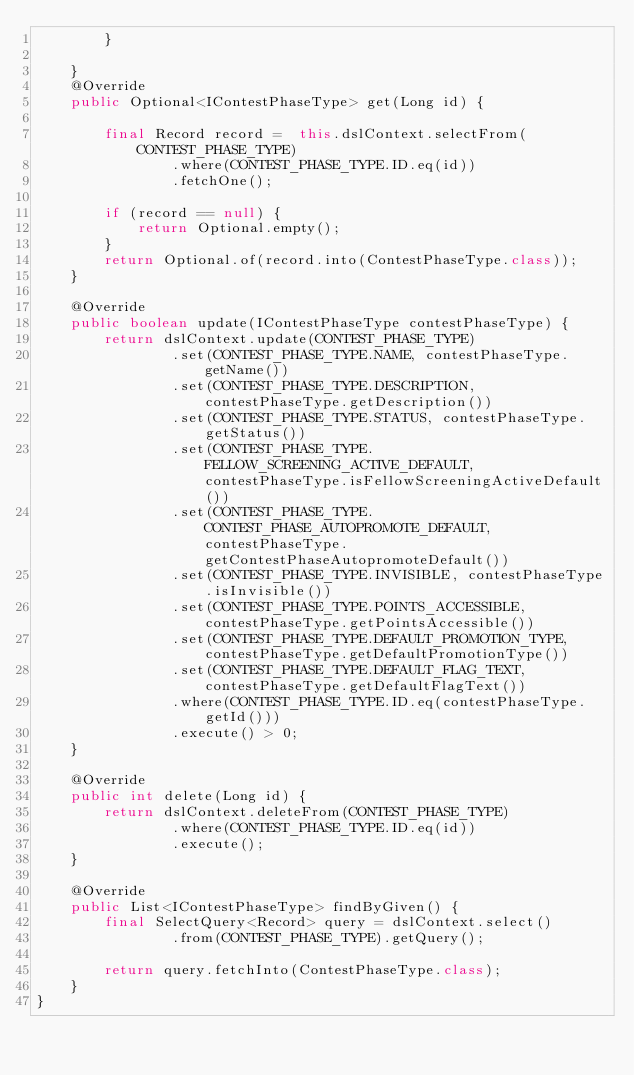Convert code to text. <code><loc_0><loc_0><loc_500><loc_500><_Java_>        }

    }
    @Override
    public Optional<IContestPhaseType> get(Long id) {

        final Record record =  this.dslContext.selectFrom(CONTEST_PHASE_TYPE)
                .where(CONTEST_PHASE_TYPE.ID.eq(id))
                .fetchOne();

        if (record == null) {
            return Optional.empty();
        }
        return Optional.of(record.into(ContestPhaseType.class));
    }

    @Override
    public boolean update(IContestPhaseType contestPhaseType) {
        return dslContext.update(CONTEST_PHASE_TYPE)
                .set(CONTEST_PHASE_TYPE.NAME, contestPhaseType.getName())
                .set(CONTEST_PHASE_TYPE.DESCRIPTION, contestPhaseType.getDescription())
                .set(CONTEST_PHASE_TYPE.STATUS, contestPhaseType.getStatus())
                .set(CONTEST_PHASE_TYPE.FELLOW_SCREENING_ACTIVE_DEFAULT, contestPhaseType.isFellowScreeningActiveDefault())
                .set(CONTEST_PHASE_TYPE.CONTEST_PHASE_AUTOPROMOTE_DEFAULT, contestPhaseType.getContestPhaseAutopromoteDefault())
                .set(CONTEST_PHASE_TYPE.INVISIBLE, contestPhaseType.isInvisible())
                .set(CONTEST_PHASE_TYPE.POINTS_ACCESSIBLE, contestPhaseType.getPointsAccessible())
                .set(CONTEST_PHASE_TYPE.DEFAULT_PROMOTION_TYPE, contestPhaseType.getDefaultPromotionType())
                .set(CONTEST_PHASE_TYPE.DEFAULT_FLAG_TEXT, contestPhaseType.getDefaultFlagText())
                .where(CONTEST_PHASE_TYPE.ID.eq(contestPhaseType.getId()))
                .execute() > 0;
    }

    @Override
    public int delete(Long id) {
        return dslContext.deleteFrom(CONTEST_PHASE_TYPE)
                .where(CONTEST_PHASE_TYPE.ID.eq(id))
                .execute();
    }

    @Override
    public List<IContestPhaseType> findByGiven() {
        final SelectQuery<Record> query = dslContext.select()
                .from(CONTEST_PHASE_TYPE).getQuery();

        return query.fetchInto(ContestPhaseType.class);
    }
}

</code> 